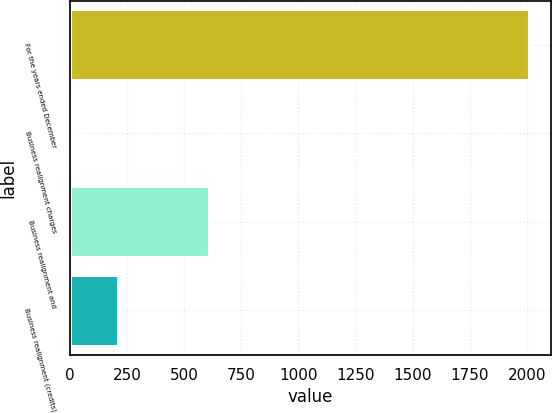Convert chart to OTSL. <chart><loc_0><loc_0><loc_500><loc_500><bar_chart><fcel>For the years ended December<fcel>Business realignment charges<fcel>Business realignment and<fcel>Business realignment (credits)<nl><fcel>2007<fcel>12.6<fcel>610.92<fcel>212.04<nl></chart> 